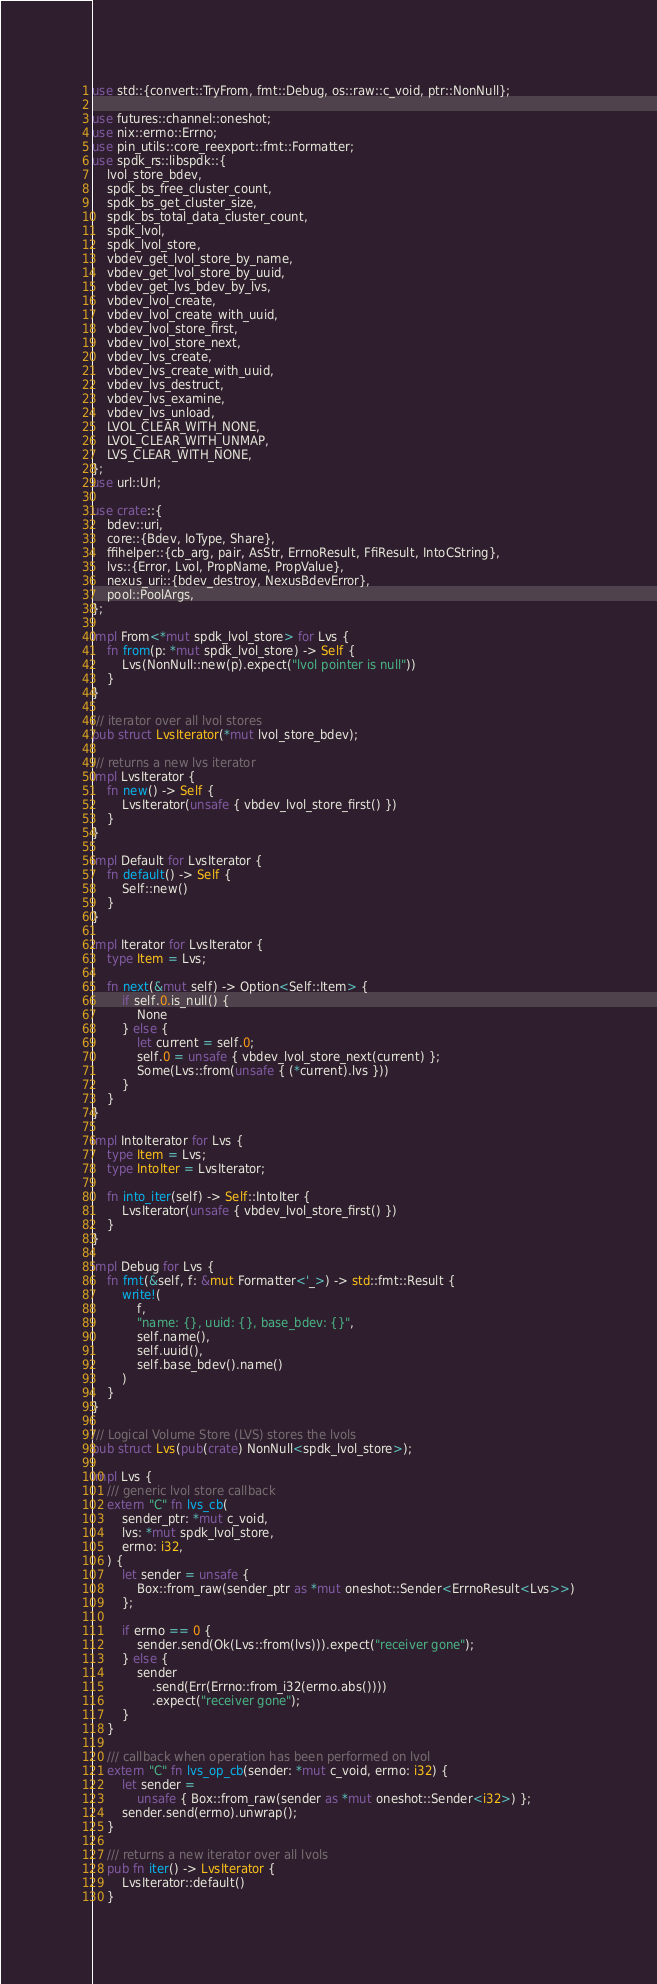<code> <loc_0><loc_0><loc_500><loc_500><_Rust_>use std::{convert::TryFrom, fmt::Debug, os::raw::c_void, ptr::NonNull};

use futures::channel::oneshot;
use nix::errno::Errno;
use pin_utils::core_reexport::fmt::Formatter;
use spdk_rs::libspdk::{
    lvol_store_bdev,
    spdk_bs_free_cluster_count,
    spdk_bs_get_cluster_size,
    spdk_bs_total_data_cluster_count,
    spdk_lvol,
    spdk_lvol_store,
    vbdev_get_lvol_store_by_name,
    vbdev_get_lvol_store_by_uuid,
    vbdev_get_lvs_bdev_by_lvs,
    vbdev_lvol_create,
    vbdev_lvol_create_with_uuid,
    vbdev_lvol_store_first,
    vbdev_lvol_store_next,
    vbdev_lvs_create,
    vbdev_lvs_create_with_uuid,
    vbdev_lvs_destruct,
    vbdev_lvs_examine,
    vbdev_lvs_unload,
    LVOL_CLEAR_WITH_NONE,
    LVOL_CLEAR_WITH_UNMAP,
    LVS_CLEAR_WITH_NONE,
};
use url::Url;

use crate::{
    bdev::uri,
    core::{Bdev, IoType, Share},
    ffihelper::{cb_arg, pair, AsStr, ErrnoResult, FfiResult, IntoCString},
    lvs::{Error, Lvol, PropName, PropValue},
    nexus_uri::{bdev_destroy, NexusBdevError},
    pool::PoolArgs,
};

impl From<*mut spdk_lvol_store> for Lvs {
    fn from(p: *mut spdk_lvol_store) -> Self {
        Lvs(NonNull::new(p).expect("lvol pointer is null"))
    }
}

/// iterator over all lvol stores
pub struct LvsIterator(*mut lvol_store_bdev);

/// returns a new lvs iterator
impl LvsIterator {
    fn new() -> Self {
        LvsIterator(unsafe { vbdev_lvol_store_first() })
    }
}

impl Default for LvsIterator {
    fn default() -> Self {
        Self::new()
    }
}

impl Iterator for LvsIterator {
    type Item = Lvs;

    fn next(&mut self) -> Option<Self::Item> {
        if self.0.is_null() {
            None
        } else {
            let current = self.0;
            self.0 = unsafe { vbdev_lvol_store_next(current) };
            Some(Lvs::from(unsafe { (*current).lvs }))
        }
    }
}

impl IntoIterator for Lvs {
    type Item = Lvs;
    type IntoIter = LvsIterator;

    fn into_iter(self) -> Self::IntoIter {
        LvsIterator(unsafe { vbdev_lvol_store_first() })
    }
}

impl Debug for Lvs {
    fn fmt(&self, f: &mut Formatter<'_>) -> std::fmt::Result {
        write!(
            f,
            "name: {}, uuid: {}, base_bdev: {}",
            self.name(),
            self.uuid(),
            self.base_bdev().name()
        )
    }
}

/// Logical Volume Store (LVS) stores the lvols
pub struct Lvs(pub(crate) NonNull<spdk_lvol_store>);

impl Lvs {
    /// generic lvol store callback
    extern "C" fn lvs_cb(
        sender_ptr: *mut c_void,
        lvs: *mut spdk_lvol_store,
        errno: i32,
    ) {
        let sender = unsafe {
            Box::from_raw(sender_ptr as *mut oneshot::Sender<ErrnoResult<Lvs>>)
        };

        if errno == 0 {
            sender.send(Ok(Lvs::from(lvs))).expect("receiver gone");
        } else {
            sender
                .send(Err(Errno::from_i32(errno.abs())))
                .expect("receiver gone");
        }
    }

    /// callback when operation has been performed on lvol
    extern "C" fn lvs_op_cb(sender: *mut c_void, errno: i32) {
        let sender =
            unsafe { Box::from_raw(sender as *mut oneshot::Sender<i32>) };
        sender.send(errno).unwrap();
    }

    /// returns a new iterator over all lvols
    pub fn iter() -> LvsIterator {
        LvsIterator::default()
    }
</code> 